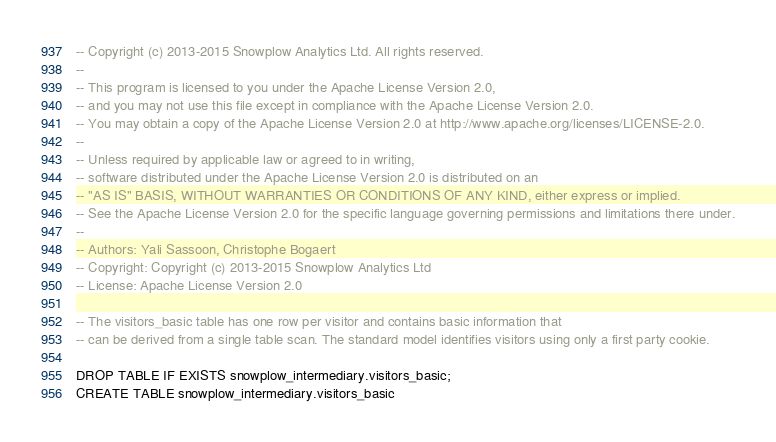Convert code to text. <code><loc_0><loc_0><loc_500><loc_500><_SQL_>-- Copyright (c) 2013-2015 Snowplow Analytics Ltd. All rights reserved.
--
-- This program is licensed to you under the Apache License Version 2.0,
-- and you may not use this file except in compliance with the Apache License Version 2.0.
-- You may obtain a copy of the Apache License Version 2.0 at http://www.apache.org/licenses/LICENSE-2.0.
--
-- Unless required by applicable law or agreed to in writing,
-- software distributed under the Apache License Version 2.0 is distributed on an
-- "AS IS" BASIS, WITHOUT WARRANTIES OR CONDITIONS OF ANY KIND, either express or implied.
-- See the Apache License Version 2.0 for the specific language governing permissions and limitations there under.
--
-- Authors: Yali Sassoon, Christophe Bogaert
-- Copyright: Copyright (c) 2013-2015 Snowplow Analytics Ltd
-- License: Apache License Version 2.0

-- The visitors_basic table has one row per visitor and contains basic information that
-- can be derived from a single table scan. The standard model identifies visitors using only a first party cookie.

DROP TABLE IF EXISTS snowplow_intermediary.visitors_basic;
CREATE TABLE snowplow_intermediary.visitors_basic</code> 